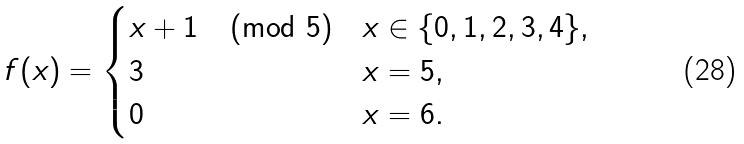Convert formula to latex. <formula><loc_0><loc_0><loc_500><loc_500>f ( x ) = \begin{cases} x + 1 \pmod { 5 } & x \in \{ 0 , 1 , 2 , 3 , 4 \} , \\ 3 & x = 5 , \\ 0 & x = 6 . \end{cases}</formula> 